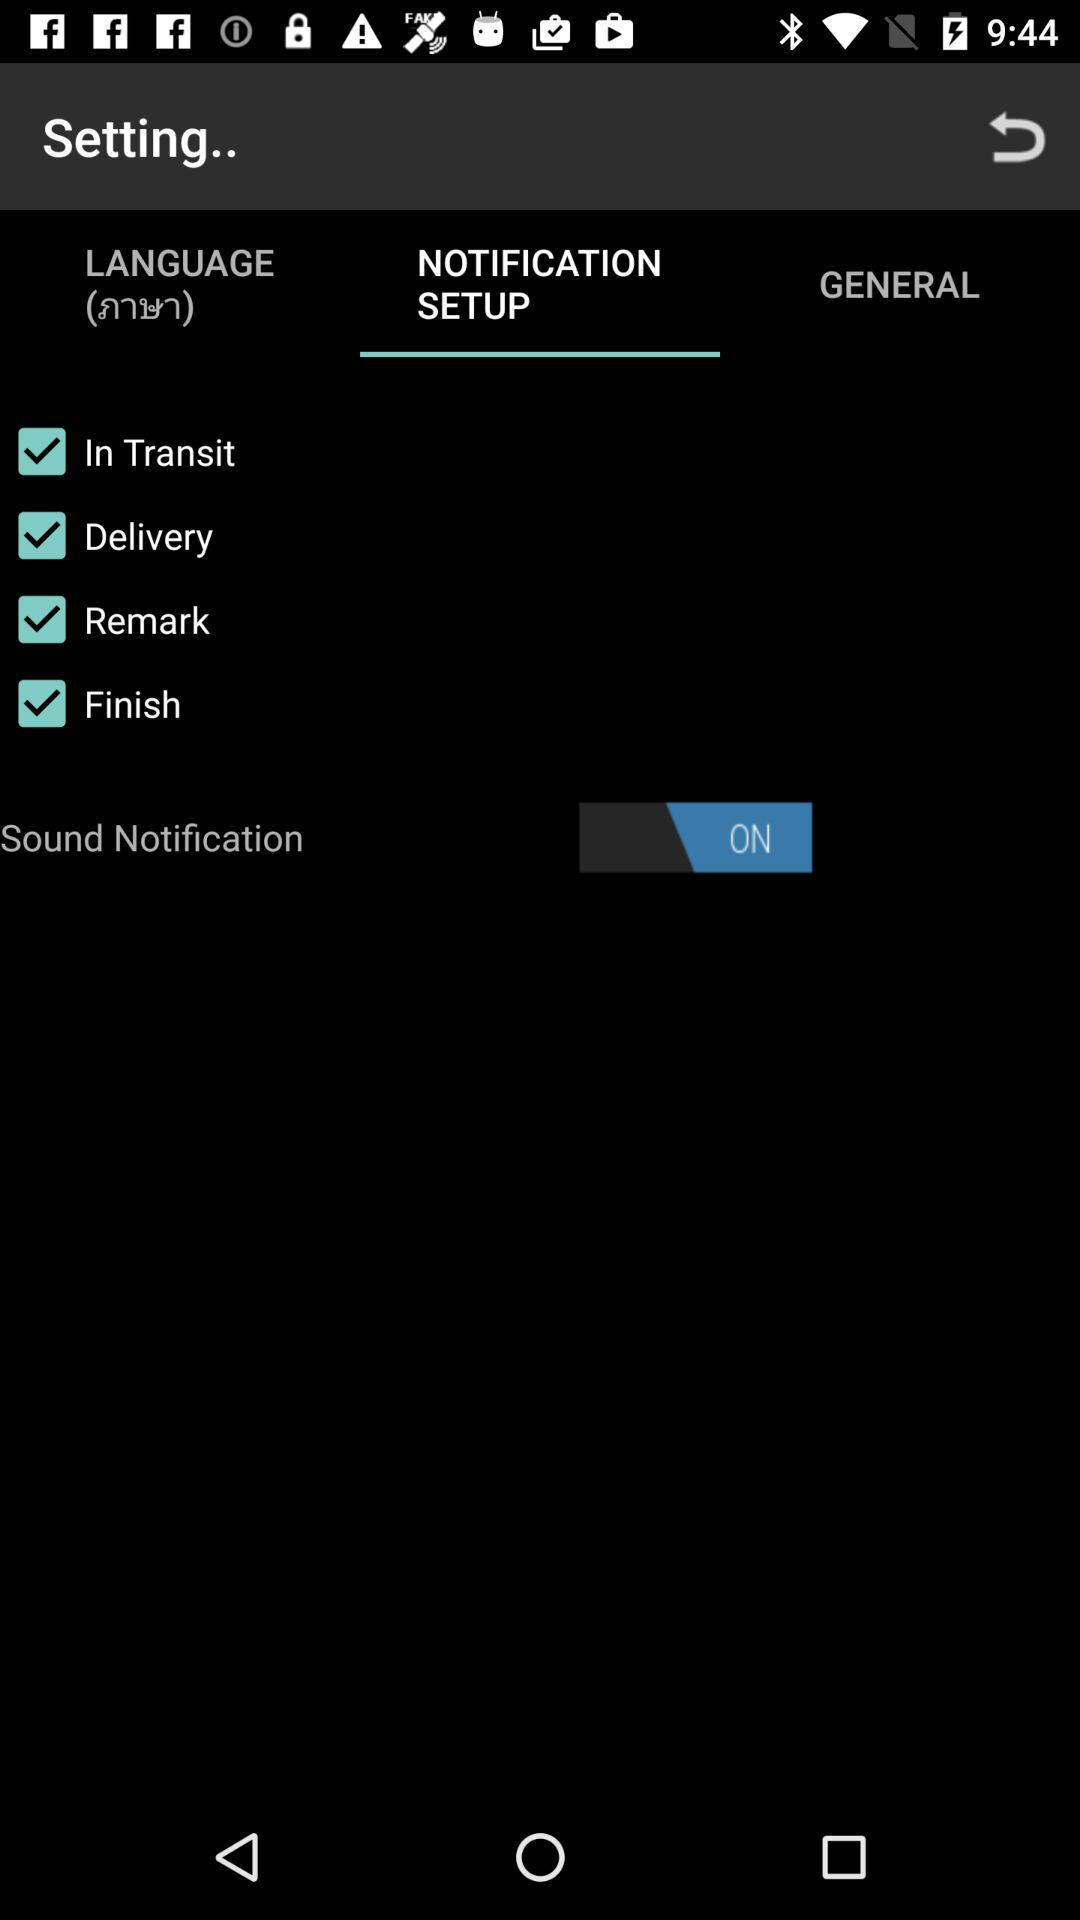What is the status of "Sound Notification"? The status is "on". 